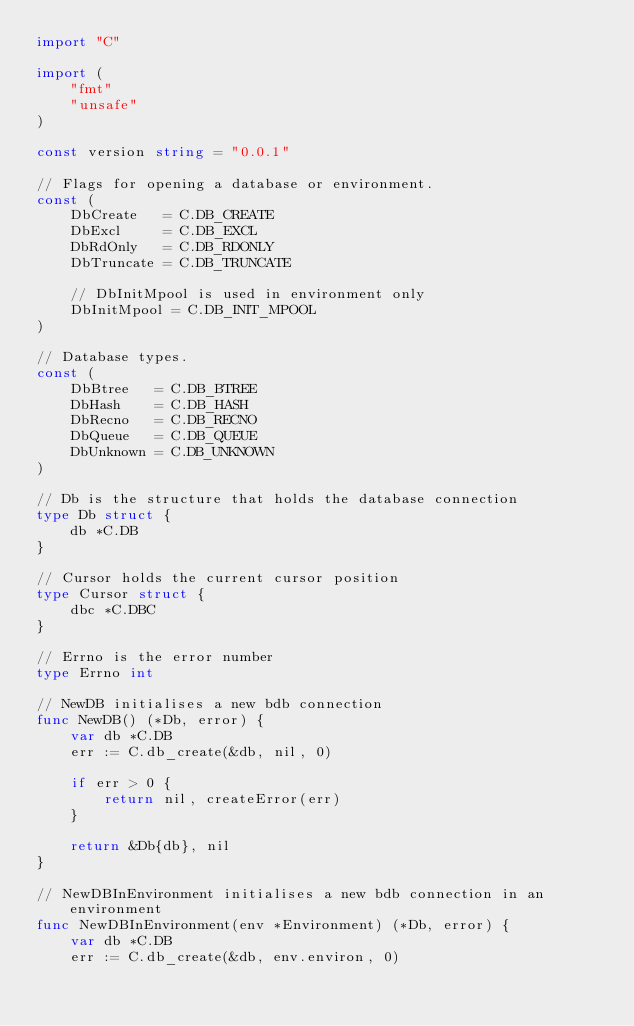Convert code to text. <code><loc_0><loc_0><loc_500><loc_500><_Go_>import "C"

import (
	"fmt"
	"unsafe"
)

const version string = "0.0.1"

// Flags for opening a database or environment.
const (
	DbCreate   = C.DB_CREATE
	DbExcl     = C.DB_EXCL
	DbRdOnly   = C.DB_RDONLY
	DbTruncate = C.DB_TRUNCATE

	// DbInitMpool is used in environment only
	DbInitMpool = C.DB_INIT_MPOOL
)

// Database types.
const (
	DbBtree   = C.DB_BTREE
	DbHash    = C.DB_HASH
	DbRecno   = C.DB_RECNO
	DbQueue   = C.DB_QUEUE
	DbUnknown = C.DB_UNKNOWN
)

// Db is the structure that holds the database connection
type Db struct {
	db *C.DB
}

// Cursor holds the current cursor position
type Cursor struct {
	dbc *C.DBC
}

// Errno is the error number
type Errno int

// NewDB initialises a new bdb connection
func NewDB() (*Db, error) {
	var db *C.DB
	err := C.db_create(&db, nil, 0)

	if err > 0 {
		return nil, createError(err)
	}

	return &Db{db}, nil
}

// NewDBInEnvironment initialises a new bdb connection in an environment
func NewDBInEnvironment(env *Environment) (*Db, error) {
	var db *C.DB
	err := C.db_create(&db, env.environ, 0)
</code> 